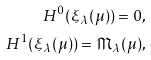<formula> <loc_0><loc_0><loc_500><loc_500>H ^ { 0 } ( \xi _ { \lambda } ( \mu ) ) = 0 , \\ H ^ { 1 } ( \xi _ { \lambda } ( \mu ) ) = \mathfrak { M } _ { \lambda } ( \mu ) ,</formula> 